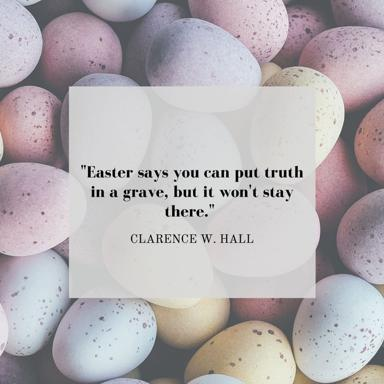What is the image featuring Easter eggs trying to convey? This image combines the traditional symbolism of Easter eggs with the thought-provoking quote by Clarence W. Hall. Easter eggs, which typically represent new life and hope, are presented here with varied pastel colors that evoke a sense of renewal and peace. The inclusion of the quote within this serene collection of eggs amplifies its message - affirming that truth, like life, is resilient and will emerge triumphantly. The visual juxtaposition invites viewers to reflect on the enduring power of truth and the hopeful spirit of the Easter season. 